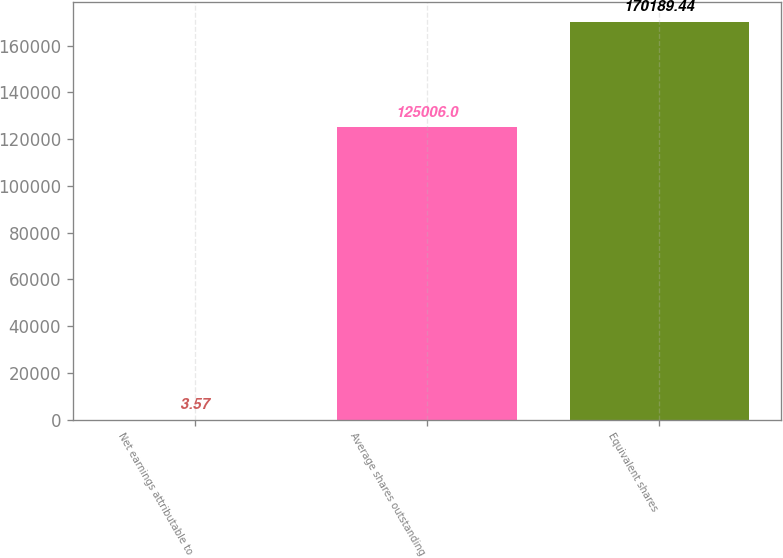Convert chart to OTSL. <chart><loc_0><loc_0><loc_500><loc_500><bar_chart><fcel>Net earnings attributable to<fcel>Average shares outstanding<fcel>Equivalent shares<nl><fcel>3.57<fcel>125006<fcel>170189<nl></chart> 